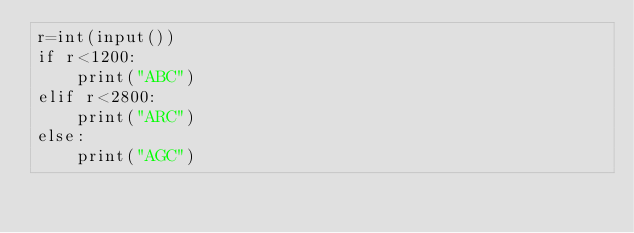<code> <loc_0><loc_0><loc_500><loc_500><_Python_>r=int(input())
if r<1200:
    print("ABC")
elif r<2800:
    print("ARC")
else:
    print("AGC")
</code> 